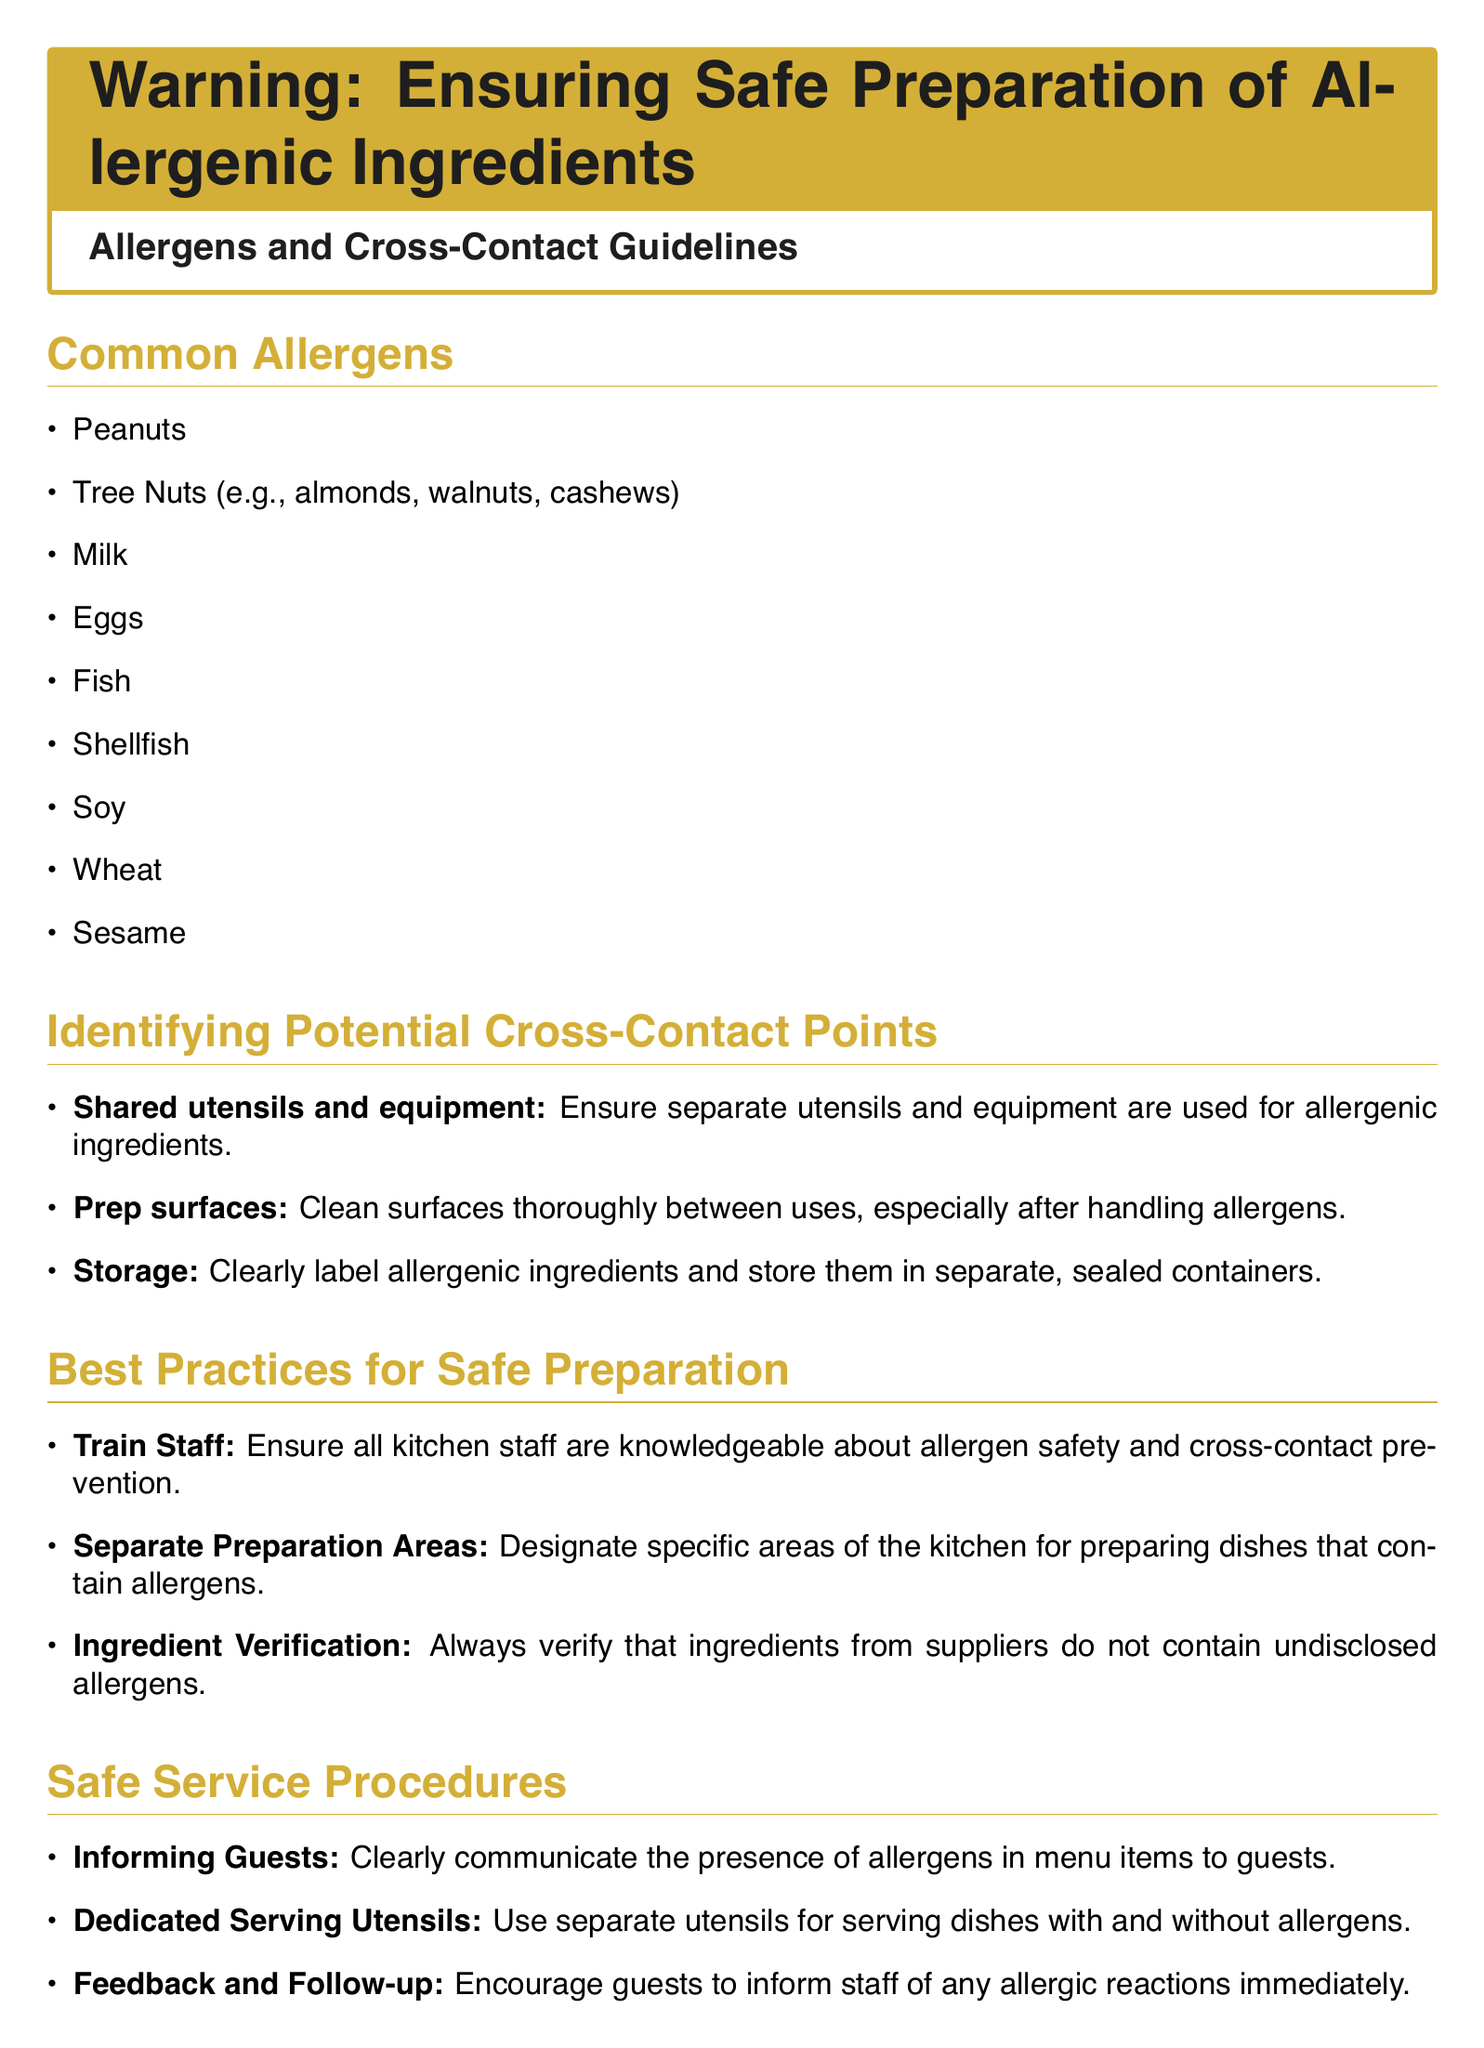What are common allergens? The document lists common allergens as peanuts, tree nuts, milk, eggs, fish, shellfish, soy, wheat, and sesame.
Answer: Peanuts, tree nuts, milk, eggs, fish, shellfish, soy, wheat, sesame What should be used for allergenic ingredients? The document states that separate utensils and equipment should be used for allergenic ingredients.
Answer: Separate utensils and equipment What is a key best practice for staff? Training staff about allergen safety and cross-contact prevention is emphasized as a key best practice.
Answer: Train Staff What should be clearly communicated to guests? The document emphasizes the need to inform guests about the presence of allergens in menu items.
Answer: Presence of allergens What is a critical action during an allergic emergency? The document highlights the importance of having a clear action plan and ensuring all staff are aware of this plan during an allergic emergency.
Answer: Action Plan 